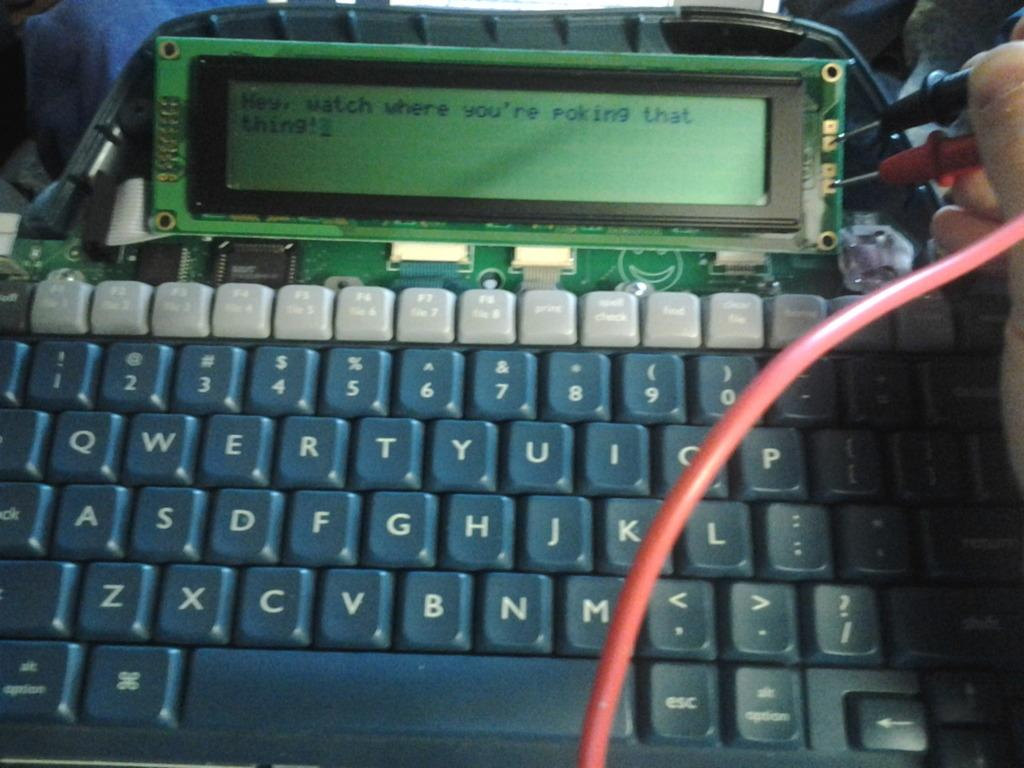<image>
Summarize the visual content of the image. A computer screen that telling the user to watch where they are poking something. 